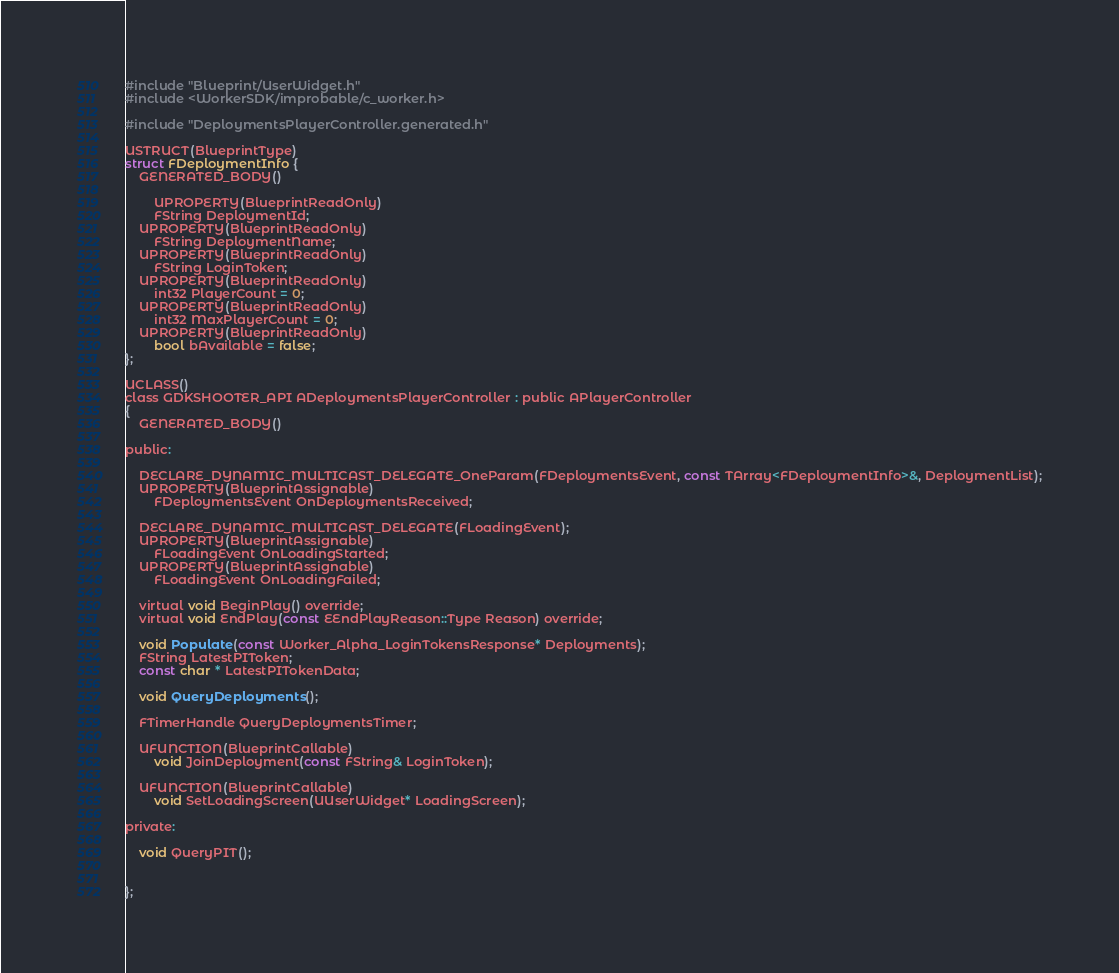Convert code to text. <code><loc_0><loc_0><loc_500><loc_500><_C_>#include "Blueprint/UserWidget.h"
#include <WorkerSDK/improbable/c_worker.h>

#include "DeploymentsPlayerController.generated.h"

USTRUCT(BlueprintType)
struct FDeploymentInfo {
	GENERATED_BODY()

		UPROPERTY(BlueprintReadOnly)
		FString DeploymentId;
	UPROPERTY(BlueprintReadOnly)
		FString DeploymentName;
	UPROPERTY(BlueprintReadOnly)
		FString LoginToken;
	UPROPERTY(BlueprintReadOnly)
		int32 PlayerCount = 0;
	UPROPERTY(BlueprintReadOnly)
		int32 MaxPlayerCount = 0;
	UPROPERTY(BlueprintReadOnly)
		bool bAvailable = false;
};

UCLASS()
class GDKSHOOTER_API ADeploymentsPlayerController : public APlayerController
{
	GENERATED_BODY()

public:

	DECLARE_DYNAMIC_MULTICAST_DELEGATE_OneParam(FDeploymentsEvent, const TArray<FDeploymentInfo>&, DeploymentList);
	UPROPERTY(BlueprintAssignable)
		FDeploymentsEvent OnDeploymentsReceived;

	DECLARE_DYNAMIC_MULTICAST_DELEGATE(FLoadingEvent);
	UPROPERTY(BlueprintAssignable)
		FLoadingEvent OnLoadingStarted;
	UPROPERTY(BlueprintAssignable)
		FLoadingEvent OnLoadingFailed;

	virtual void BeginPlay() override;
	virtual void EndPlay(const EEndPlayReason::Type Reason) override;

	void Populate(const Worker_Alpha_LoginTokensResponse* Deployments);
	FString LatestPIToken;
	const char * LatestPITokenData;

	void QueryDeployments();

	FTimerHandle QueryDeploymentsTimer;

	UFUNCTION(BlueprintCallable)
		void JoinDeployment(const FString& LoginToken);

	UFUNCTION(BlueprintCallable)
		void SetLoadingScreen(UUserWidget* LoadingScreen);

private:

	void QueryPIT();

	
};
</code> 